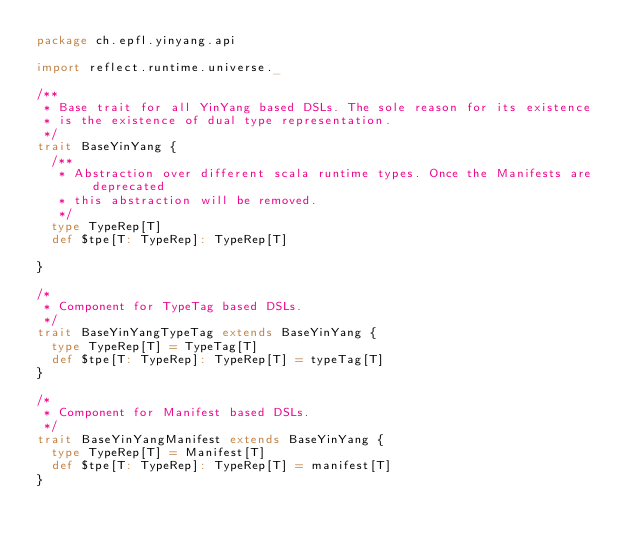Convert code to text. <code><loc_0><loc_0><loc_500><loc_500><_Scala_>package ch.epfl.yinyang.api

import reflect.runtime.universe._

/**
 * Base trait for all YinYang based DSLs. The sole reason for its existence
 * is the existence of dual type representation.
 */
trait BaseYinYang {
  /**
   * Abstraction over different scala runtime types. Once the Manifests are deprecated
   * this abstraction will be removed.
   */
  type TypeRep[T]
  def $tpe[T: TypeRep]: TypeRep[T]

}

/*
 * Component for TypeTag based DSLs.
 */
trait BaseYinYangTypeTag extends BaseYinYang {
  type TypeRep[T] = TypeTag[T]
  def $tpe[T: TypeRep]: TypeRep[T] = typeTag[T]
}

/*
 * Component for Manifest based DSLs.
 */
trait BaseYinYangManifest extends BaseYinYang {
  type TypeRep[T] = Manifest[T]
  def $tpe[T: TypeRep]: TypeRep[T] = manifest[T]
}
</code> 